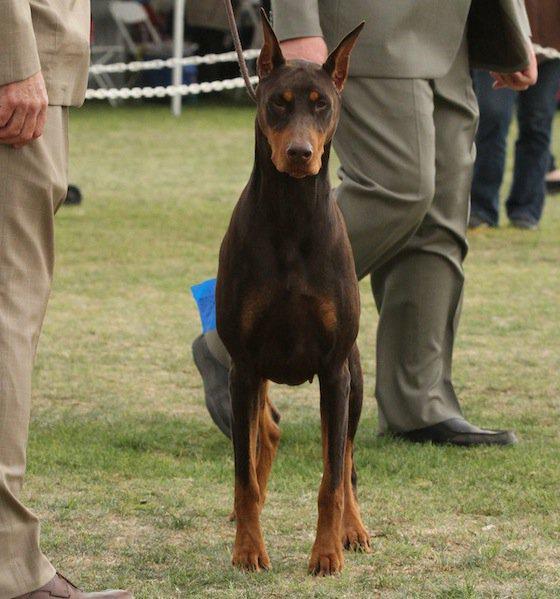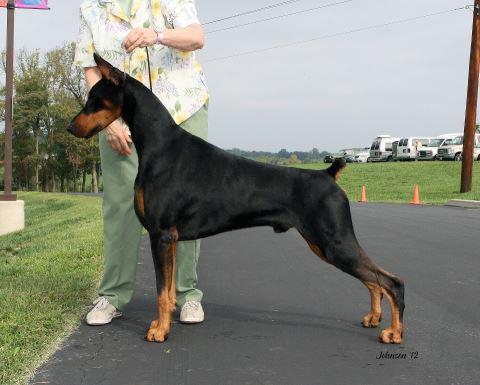The first image is the image on the left, the second image is the image on the right. Assess this claim about the two images: "Two dogs are standing.". Correct or not? Answer yes or no. Yes. The first image is the image on the left, the second image is the image on the right. For the images displayed, is the sentence "The left and right image contains the same number of dogs with one facing forward and the other facing sideways." factually correct? Answer yes or no. Yes. 